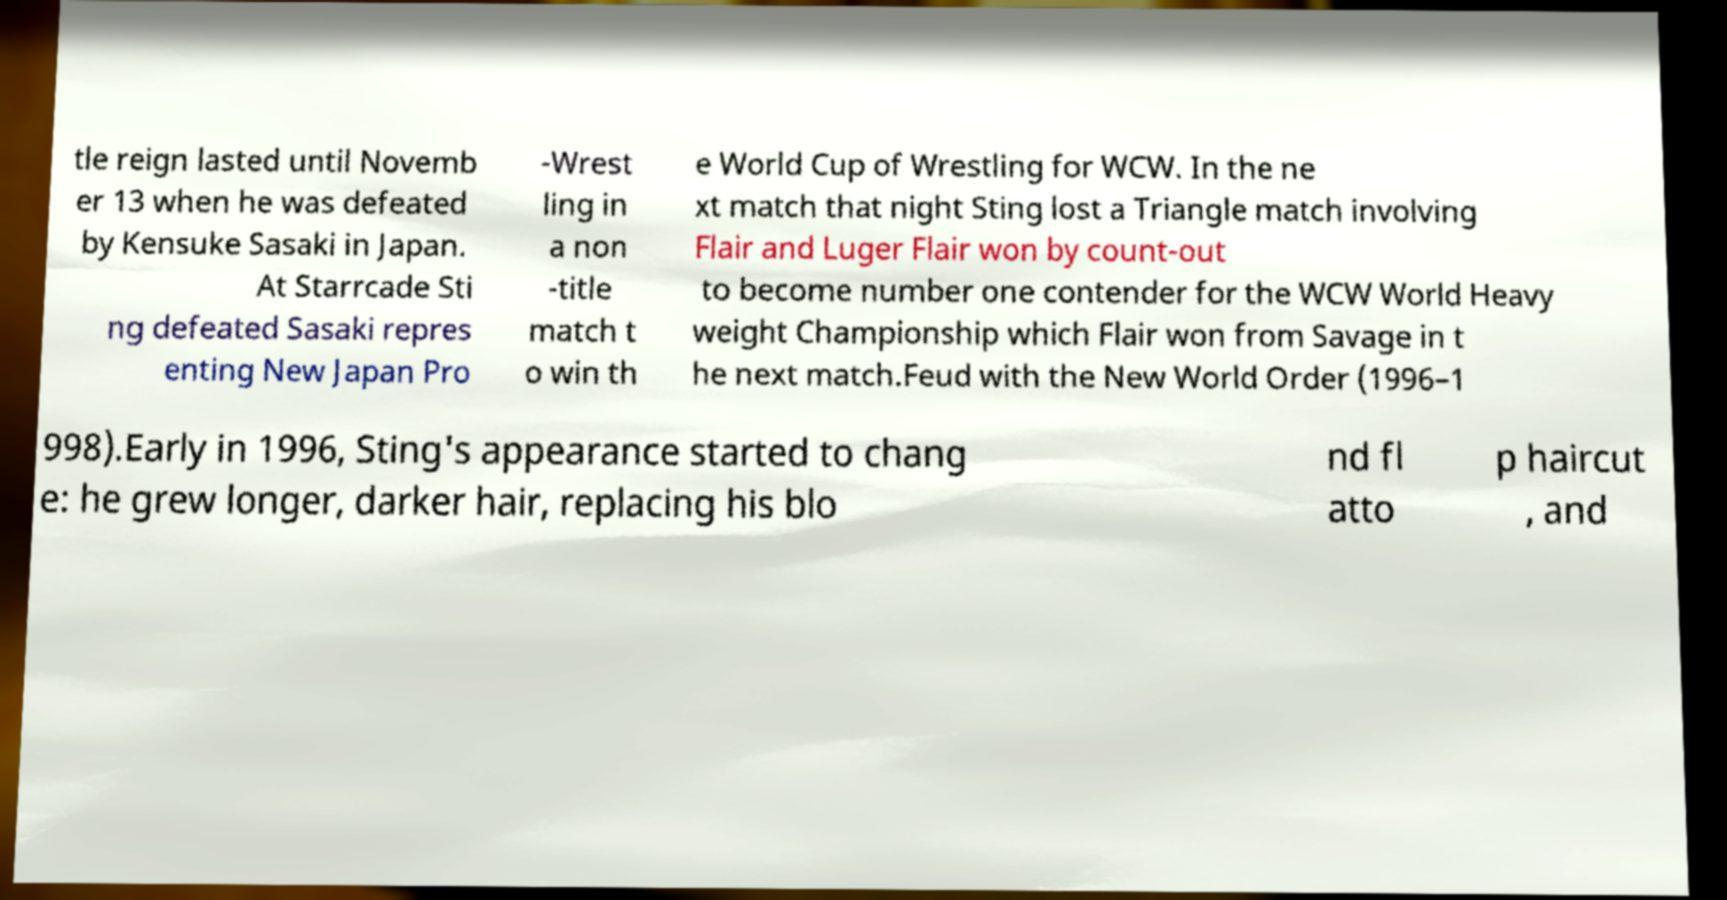Could you assist in decoding the text presented in this image and type it out clearly? tle reign lasted until Novemb er 13 when he was defeated by Kensuke Sasaki in Japan. At Starrcade Sti ng defeated Sasaki repres enting New Japan Pro -Wrest ling in a non -title match t o win th e World Cup of Wrestling for WCW. In the ne xt match that night Sting lost a Triangle match involving Flair and Luger Flair won by count-out to become number one contender for the WCW World Heavy weight Championship which Flair won from Savage in t he next match.Feud with the New World Order (1996–1 998).Early in 1996, Sting's appearance started to chang e: he grew longer, darker hair, replacing his blo nd fl atto p haircut , and 